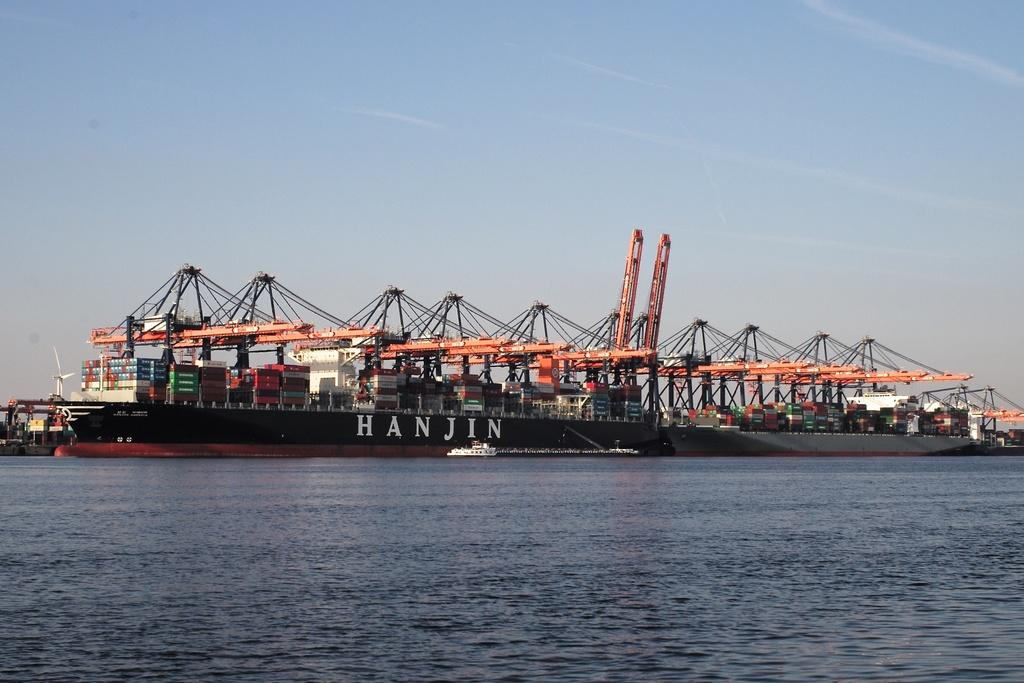<image>
Provide a brief description of the given image. A shipping container barge says Hanjin on the side in big white letters. 